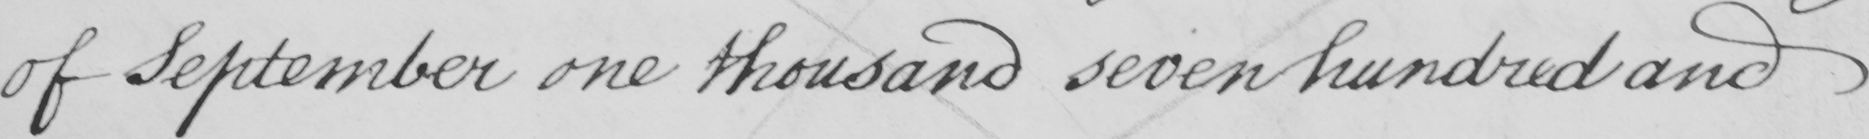Please transcribe the handwritten text in this image. of September one thousand seven hundred and 